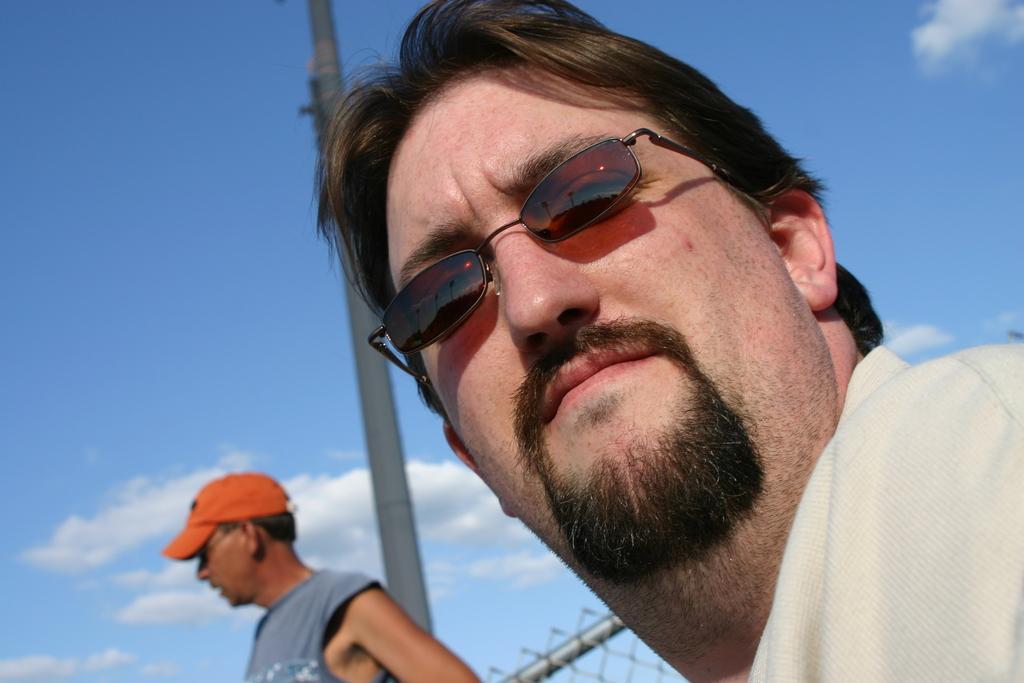Please provide a concise description of this image. In this picture there are two men and we can see fence and pole. In the background of the image we can see the sky with clouds. 